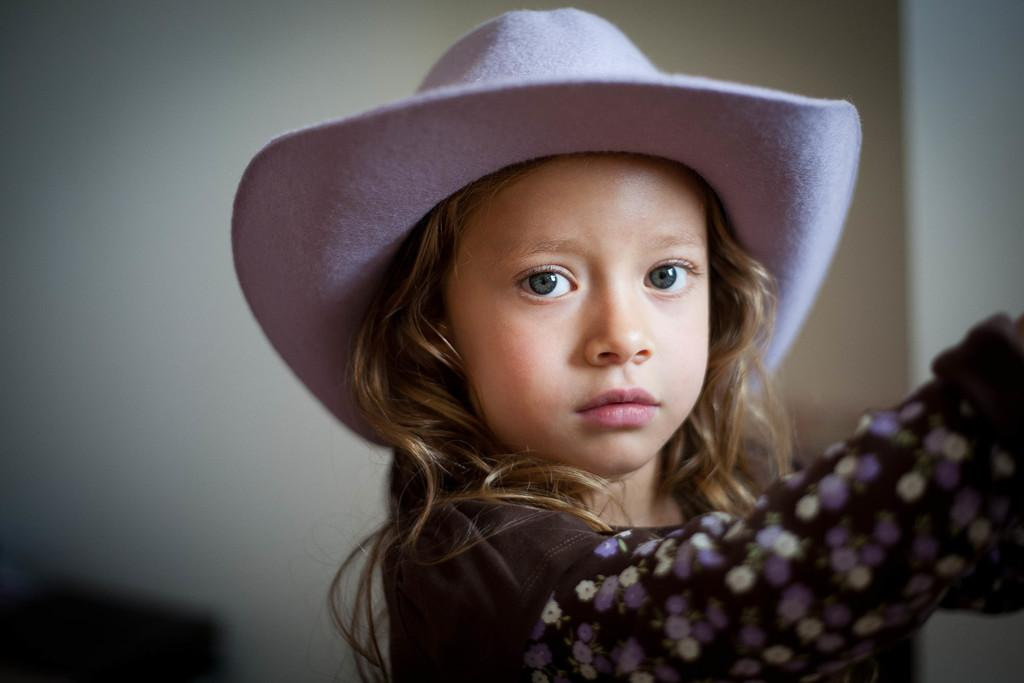What is the main subject in the foreground of the image? There is a girl in the foreground of the image. What is the girl wearing on her head? The girl is wearing a hat. Can you describe the background of the image? The background of the image is blurred. What type of pest can be seen crawling on the girl's hair in the image? There is no pest visible on the girl's hair in the image. How many snails are present on the girl's hat in the image? There are no snails present on the girl's hat in the image. 